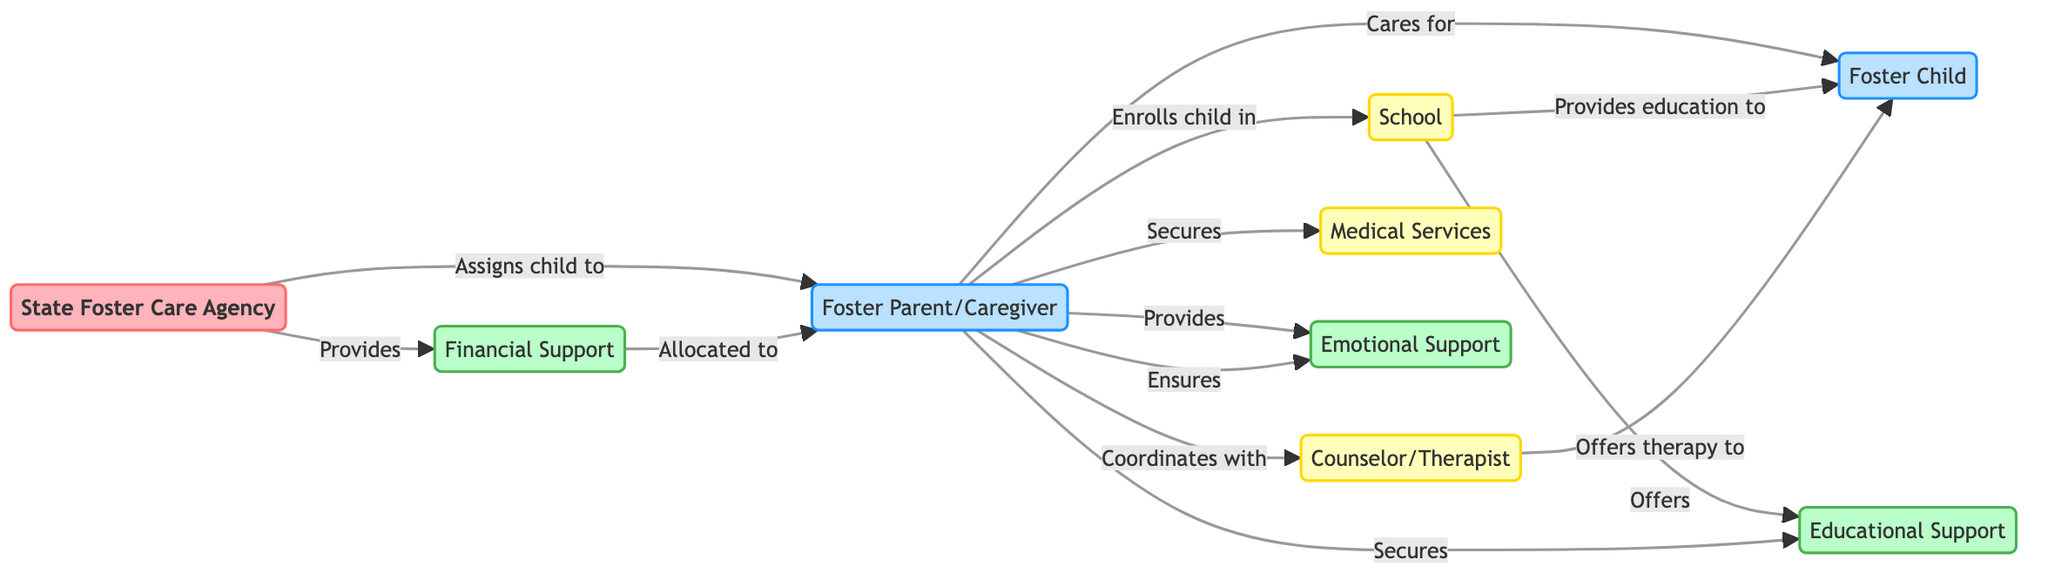What is the total number of nodes in the diagram? There are nine nodes represented in the diagram, which include: Foster Parent/Caregiver, Foster Child, State Foster Care Agency, School, Counselor/Therapist, Medical Services, Financial Support, Educational Support, and Emotional Support.
Answer: 9 Who assigns the child to the Foster Parent/Caregiver? The State Foster Care Agency is responsible for assigning the child to the Foster Parent/Caregiver, as indicated by the directed edge labeled "Assigns child to."
Answer: State Foster Care Agency What type of support is allocated to the Foster Parent/Caregiver? The diagram shows that Financial Support is allocated to the Foster Parent/Caregiver as depicted by the edge labeled "Allocated to."
Answer: Financial Support How many services does the Foster Parent/Caregiver secure? The Foster Parent/Caregiver secures a total of three services: Medical Services, Educational Support, and Emotional Support.
Answer: 3 Which node provides emotional support to the Foster Child? The Foster Parent/Caregiver provides emotional support to the Foster Child, as indicated by the directed edge labeled "Provides."
Answer: Foster Parent/Caregiver What flow of support is provided by the School to the Foster Child? The School provides educational support to the Foster Child, as shown by the directed edge labeled "Provides education to."
Answer: Educational Support Which entity coordinates with the Counselor/Therapist? The Foster Parent/Caregiver coordinates with the Counselor/Therapist as indicated by the edge labeled "Coordinates with."
Answer: Foster Parent/Caregiver Which types of support can the Foster Parent/Caregiver secure? The Foster Parent/Caregiver can secure Educational Support, Medical Services, and Emotional Support, as shown by the edges labeled "Secures" and "Provides."
Answer: Educational Support, Medical Services, Emotional Support How many edges are outgoing from the Foster Parent/Caregiver? The Foster Parent/Caregiver has five outgoing edges as depicted in the diagram, indicating their connections to the child, school, medical services, counselor, and support systems.
Answer: 5 